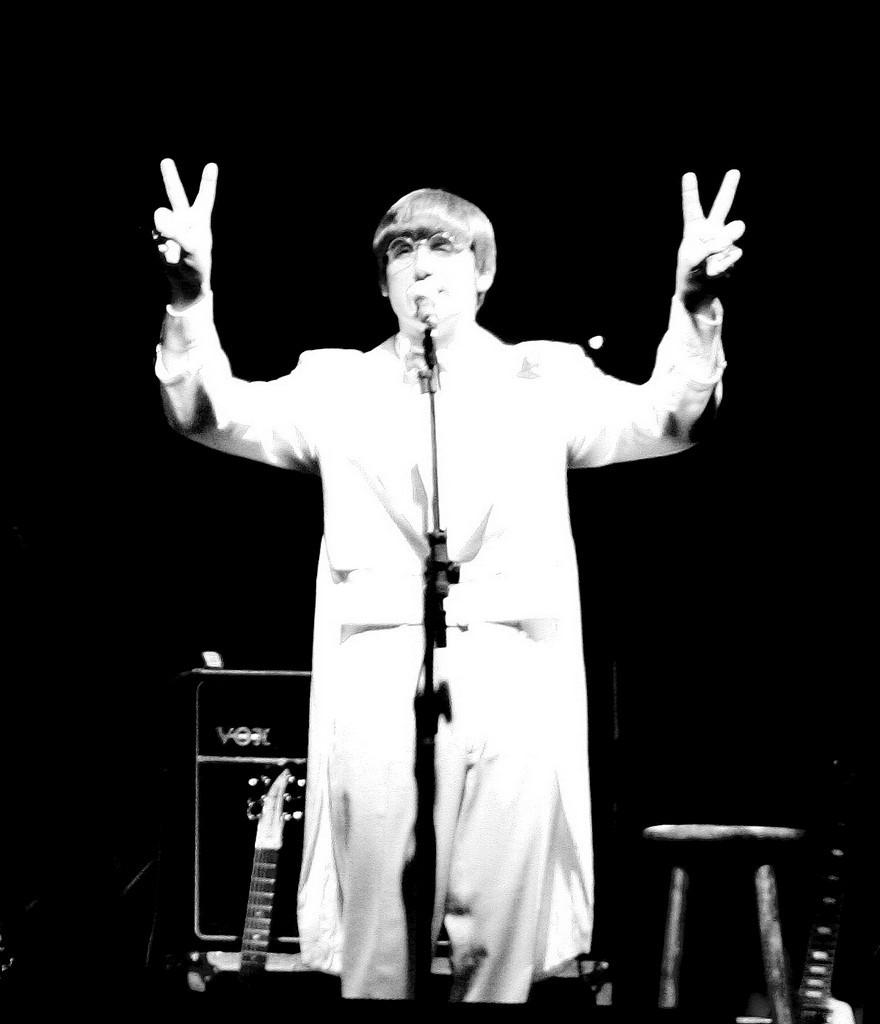What is the main subject of the image? There is a person in the image. What is the person doing in the image? The person is standing in front of a mic. Can you describe the background of the image? The background of the image is dark. What type of clover can be seen growing in the background of the image? There is no clover present in the image, as the background is dark. 